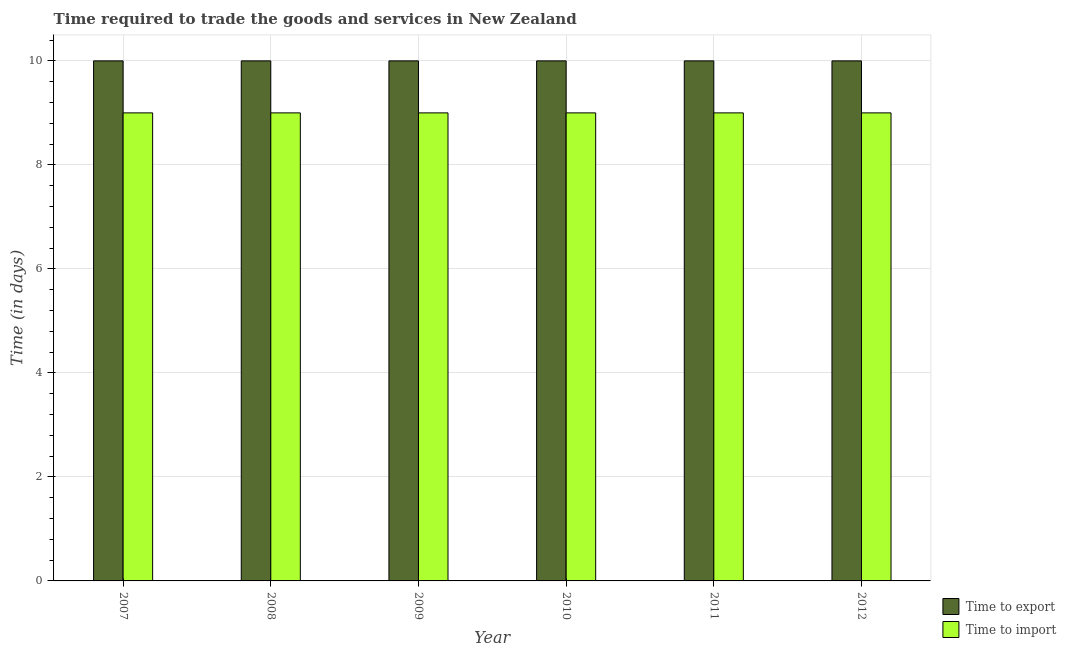Are the number of bars on each tick of the X-axis equal?
Provide a short and direct response. Yes. How many bars are there on the 1st tick from the left?
Your answer should be compact. 2. How many bars are there on the 5th tick from the right?
Offer a terse response. 2. What is the label of the 1st group of bars from the left?
Keep it short and to the point. 2007. In how many cases, is the number of bars for a given year not equal to the number of legend labels?
Provide a short and direct response. 0. What is the time to export in 2010?
Keep it short and to the point. 10. Across all years, what is the maximum time to export?
Provide a succinct answer. 10. Across all years, what is the minimum time to import?
Your answer should be compact. 9. In which year was the time to export minimum?
Offer a very short reply. 2007. What is the total time to import in the graph?
Give a very brief answer. 54. What is the difference between the time to import in 2012 and the time to export in 2007?
Your answer should be very brief. 0. What is the average time to export per year?
Your answer should be very brief. 10. In how many years, is the time to export greater than 6.4 days?
Keep it short and to the point. 6. What is the ratio of the time to import in 2007 to that in 2008?
Your answer should be compact. 1. What is the difference between the highest and the lowest time to export?
Provide a short and direct response. 0. In how many years, is the time to export greater than the average time to export taken over all years?
Provide a succinct answer. 0. Is the sum of the time to export in 2007 and 2010 greater than the maximum time to import across all years?
Your answer should be compact. Yes. What does the 2nd bar from the left in 2010 represents?
Your answer should be very brief. Time to import. What does the 1st bar from the right in 2012 represents?
Provide a succinct answer. Time to import. How many bars are there?
Make the answer very short. 12. What is the difference between two consecutive major ticks on the Y-axis?
Your answer should be very brief. 2. Are the values on the major ticks of Y-axis written in scientific E-notation?
Provide a short and direct response. No. Does the graph contain any zero values?
Your response must be concise. No. Where does the legend appear in the graph?
Ensure brevity in your answer.  Bottom right. How are the legend labels stacked?
Provide a succinct answer. Vertical. What is the title of the graph?
Make the answer very short. Time required to trade the goods and services in New Zealand. What is the label or title of the X-axis?
Give a very brief answer. Year. What is the label or title of the Y-axis?
Provide a short and direct response. Time (in days). What is the Time (in days) of Time to export in 2007?
Keep it short and to the point. 10. What is the Time (in days) of Time to import in 2008?
Provide a short and direct response. 9. What is the Time (in days) of Time to import in 2009?
Provide a succinct answer. 9. What is the Time (in days) of Time to export in 2012?
Give a very brief answer. 10. Across all years, what is the maximum Time (in days) of Time to export?
Your answer should be very brief. 10. Across all years, what is the minimum Time (in days) of Time to export?
Ensure brevity in your answer.  10. Across all years, what is the minimum Time (in days) in Time to import?
Make the answer very short. 9. What is the difference between the Time (in days) in Time to export in 2007 and that in 2008?
Ensure brevity in your answer.  0. What is the difference between the Time (in days) of Time to export in 2007 and that in 2009?
Ensure brevity in your answer.  0. What is the difference between the Time (in days) of Time to export in 2007 and that in 2010?
Your answer should be compact. 0. What is the difference between the Time (in days) of Time to import in 2008 and that in 2009?
Make the answer very short. 0. What is the difference between the Time (in days) in Time to export in 2008 and that in 2010?
Provide a short and direct response. 0. What is the difference between the Time (in days) of Time to import in 2008 and that in 2010?
Your response must be concise. 0. What is the difference between the Time (in days) of Time to export in 2008 and that in 2011?
Keep it short and to the point. 0. What is the difference between the Time (in days) of Time to import in 2008 and that in 2011?
Ensure brevity in your answer.  0. What is the difference between the Time (in days) in Time to import in 2008 and that in 2012?
Give a very brief answer. 0. What is the difference between the Time (in days) in Time to export in 2009 and that in 2011?
Your answer should be compact. 0. What is the difference between the Time (in days) in Time to export in 2009 and that in 2012?
Give a very brief answer. 0. What is the difference between the Time (in days) of Time to export in 2010 and that in 2011?
Make the answer very short. 0. What is the difference between the Time (in days) in Time to import in 2010 and that in 2011?
Your response must be concise. 0. What is the difference between the Time (in days) of Time to export in 2010 and that in 2012?
Your response must be concise. 0. What is the difference between the Time (in days) in Time to export in 2007 and the Time (in days) in Time to import in 2008?
Make the answer very short. 1. What is the difference between the Time (in days) of Time to export in 2007 and the Time (in days) of Time to import in 2010?
Your answer should be compact. 1. What is the difference between the Time (in days) of Time to export in 2007 and the Time (in days) of Time to import in 2011?
Your response must be concise. 1. What is the difference between the Time (in days) in Time to export in 2008 and the Time (in days) in Time to import in 2009?
Your answer should be compact. 1. What is the difference between the Time (in days) in Time to export in 2008 and the Time (in days) in Time to import in 2010?
Offer a very short reply. 1. What is the difference between the Time (in days) in Time to export in 2008 and the Time (in days) in Time to import in 2011?
Your answer should be very brief. 1. What is the difference between the Time (in days) in Time to export in 2008 and the Time (in days) in Time to import in 2012?
Offer a terse response. 1. What is the difference between the Time (in days) in Time to export in 2009 and the Time (in days) in Time to import in 2011?
Make the answer very short. 1. What is the difference between the Time (in days) in Time to export in 2010 and the Time (in days) in Time to import in 2011?
Your answer should be very brief. 1. What is the difference between the Time (in days) of Time to export in 2010 and the Time (in days) of Time to import in 2012?
Your answer should be compact. 1. In the year 2007, what is the difference between the Time (in days) of Time to export and Time (in days) of Time to import?
Your answer should be compact. 1. In the year 2012, what is the difference between the Time (in days) of Time to export and Time (in days) of Time to import?
Your answer should be very brief. 1. What is the ratio of the Time (in days) of Time to import in 2007 to that in 2008?
Ensure brevity in your answer.  1. What is the ratio of the Time (in days) in Time to export in 2007 to that in 2009?
Ensure brevity in your answer.  1. What is the ratio of the Time (in days) of Time to export in 2007 to that in 2011?
Make the answer very short. 1. What is the ratio of the Time (in days) in Time to import in 2007 to that in 2012?
Keep it short and to the point. 1. What is the ratio of the Time (in days) in Time to import in 2008 to that in 2009?
Offer a terse response. 1. What is the ratio of the Time (in days) of Time to export in 2008 to that in 2010?
Your answer should be very brief. 1. What is the ratio of the Time (in days) in Time to import in 2008 to that in 2010?
Your answer should be compact. 1. What is the ratio of the Time (in days) of Time to export in 2008 to that in 2011?
Give a very brief answer. 1. What is the ratio of the Time (in days) in Time to import in 2008 to that in 2011?
Keep it short and to the point. 1. What is the ratio of the Time (in days) in Time to export in 2009 to that in 2010?
Your answer should be compact. 1. What is the ratio of the Time (in days) of Time to import in 2009 to that in 2010?
Give a very brief answer. 1. What is the ratio of the Time (in days) in Time to import in 2009 to that in 2012?
Your response must be concise. 1. What is the ratio of the Time (in days) in Time to export in 2010 to that in 2011?
Provide a short and direct response. 1. What is the ratio of the Time (in days) in Time to export in 2010 to that in 2012?
Offer a very short reply. 1. What is the ratio of the Time (in days) of Time to export in 2011 to that in 2012?
Provide a short and direct response. 1. What is the difference between the highest and the lowest Time (in days) in Time to import?
Provide a short and direct response. 0. 